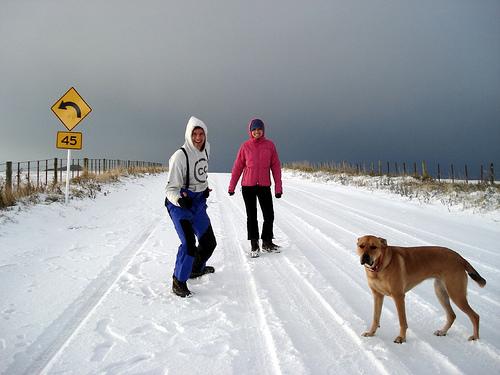How high is the snow?
Answer briefly. 1 inch. Is this a location that would normally see snow?
Short answer required. Yes. What number is shown?
Keep it brief. 45. 